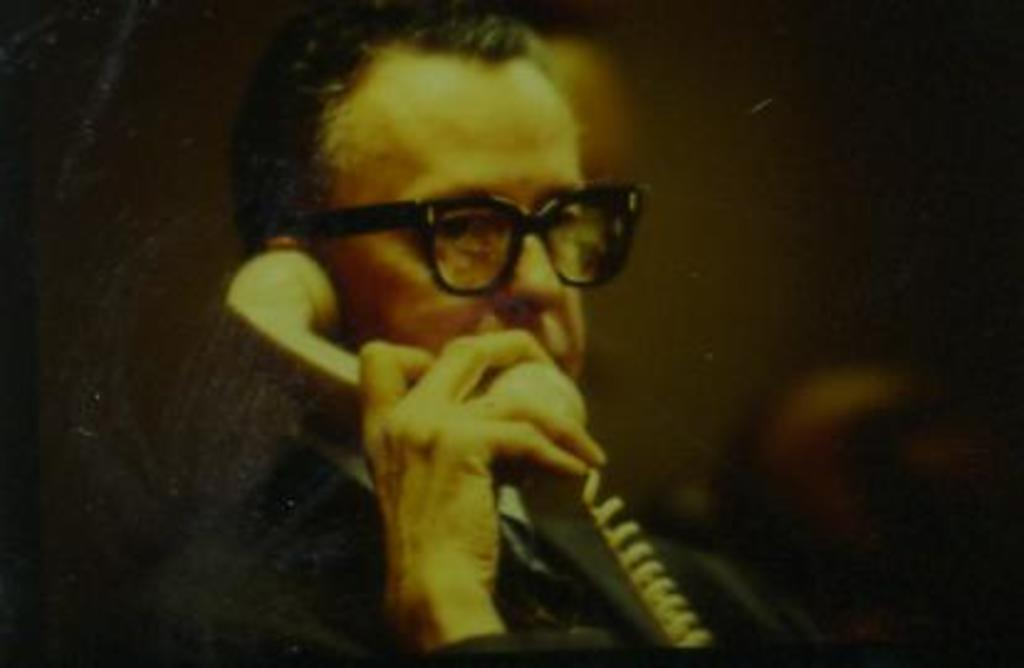What is the main subject of the image? There is a man in the image. What is the man holding in his hand? The man is holding a telephone in his hand. In which direction is the man looking? The man is looking towards the right side. What is the color of the background in the image? The background of the image is black. How many books are visible on the stage in the image? There are no books or stage present in the image; it features a man holding a telephone with a black background. 